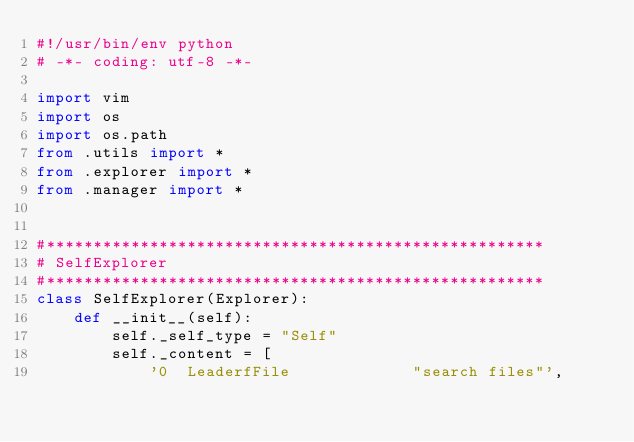Convert code to text. <code><loc_0><loc_0><loc_500><loc_500><_Python_>#!/usr/bin/env python
# -*- coding: utf-8 -*-

import vim
import os
import os.path
from .utils import *
from .explorer import *
from .manager import *


#*****************************************************
# SelfExplorer
#*****************************************************
class SelfExplorer(Explorer):
    def __init__(self):
        self._self_type = "Self"
        self._content = [
            '0  LeaderfFile             "search files"',</code> 